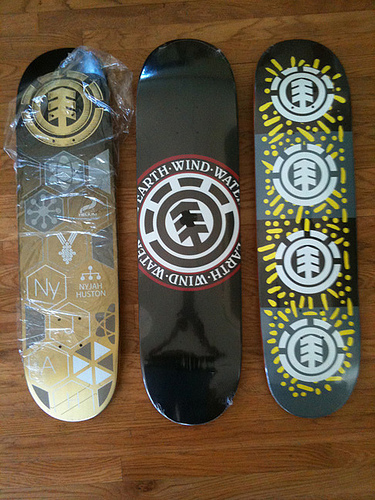<image>
Is the plank to the left of the arrow? No. The plank is not to the left of the arrow. From this viewpoint, they have a different horizontal relationship. 